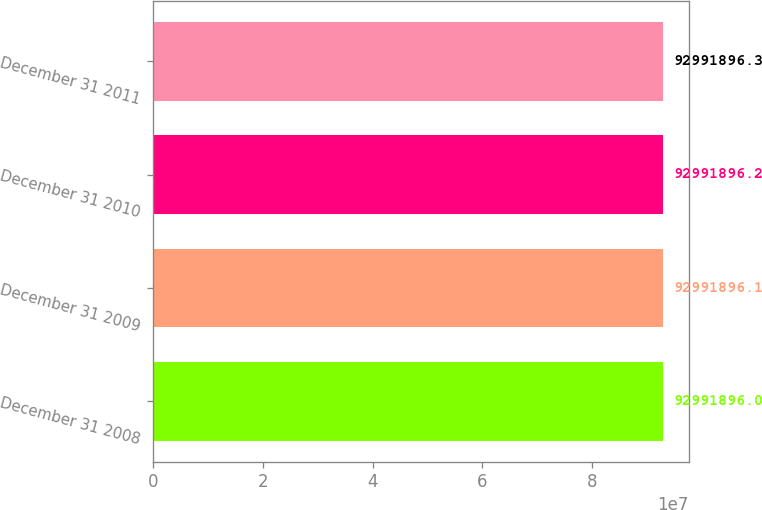<chart> <loc_0><loc_0><loc_500><loc_500><bar_chart><fcel>December 31 2008<fcel>December 31 2009<fcel>December 31 2010<fcel>December 31 2011<nl><fcel>9.29919e+07<fcel>9.29919e+07<fcel>9.29919e+07<fcel>9.29919e+07<nl></chart> 